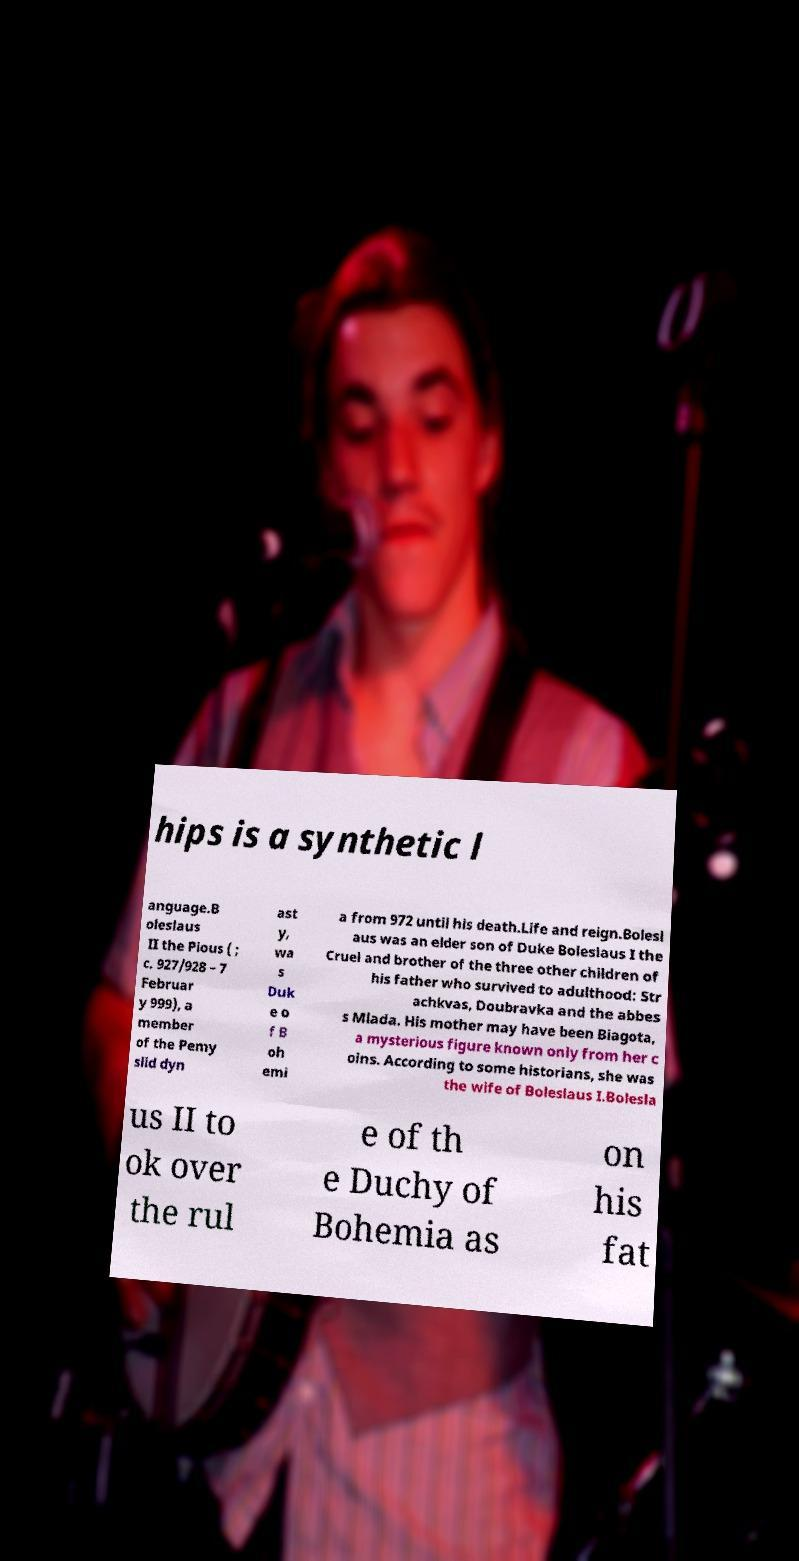I need the written content from this picture converted into text. Can you do that? hips is a synthetic l anguage.B oleslaus II the Pious ( ; c. 927/928 – 7 Februar y 999), a member of the Pemy slid dyn ast y, wa s Duk e o f B oh emi a from 972 until his death.Life and reign.Bolesl aus was an elder son of Duke Boleslaus I the Cruel and brother of the three other children of his father who survived to adulthood: Str achkvas, Doubravka and the abbes s Mlada. His mother may have been Biagota, a mysterious figure known only from her c oins. According to some historians, she was the wife of Boleslaus I.Bolesla us II to ok over the rul e of th e Duchy of Bohemia as on his fat 